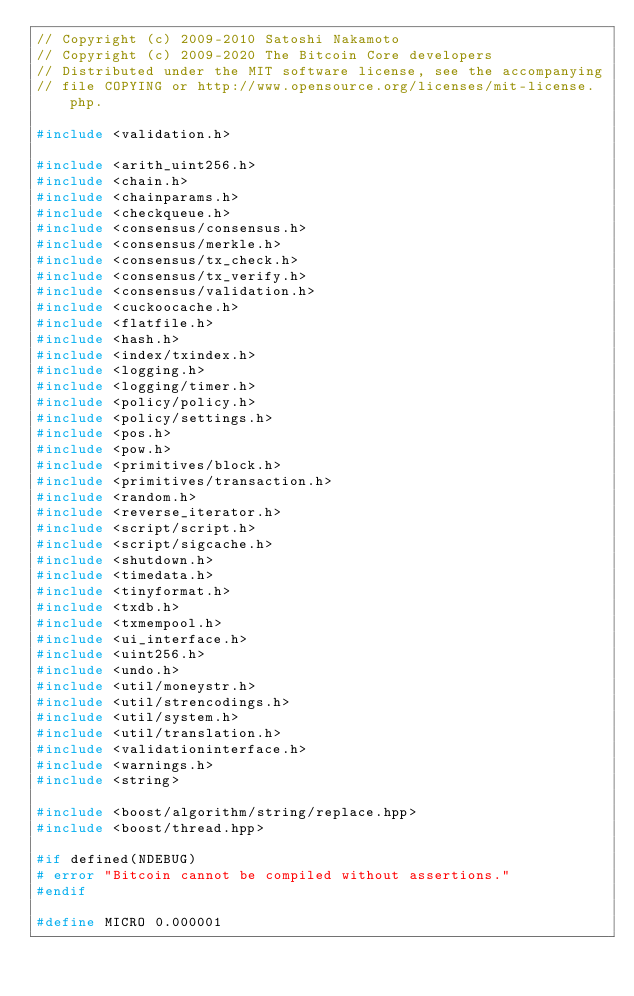Convert code to text. <code><loc_0><loc_0><loc_500><loc_500><_C++_>// Copyright (c) 2009-2010 Satoshi Nakamoto
// Copyright (c) 2009-2020 The Bitcoin Core developers
// Distributed under the MIT software license, see the accompanying
// file COPYING or http://www.opensource.org/licenses/mit-license.php.

#include <validation.h>

#include <arith_uint256.h>
#include <chain.h>
#include <chainparams.h>
#include <checkqueue.h>
#include <consensus/consensus.h>
#include <consensus/merkle.h>
#include <consensus/tx_check.h>
#include <consensus/tx_verify.h>
#include <consensus/validation.h>
#include <cuckoocache.h>
#include <flatfile.h>
#include <hash.h>
#include <index/txindex.h>
#include <logging.h>
#include <logging/timer.h>
#include <policy/policy.h>
#include <policy/settings.h>
#include <pos.h>
#include <pow.h>
#include <primitives/block.h>
#include <primitives/transaction.h>
#include <random.h>
#include <reverse_iterator.h>
#include <script/script.h>
#include <script/sigcache.h>
#include <shutdown.h>
#include <timedata.h>
#include <tinyformat.h>
#include <txdb.h>
#include <txmempool.h>
#include <ui_interface.h>
#include <uint256.h>
#include <undo.h>
#include <util/moneystr.h>
#include <util/strencodings.h>
#include <util/system.h>
#include <util/translation.h>
#include <validationinterface.h>
#include <warnings.h>
#include <string>

#include <boost/algorithm/string/replace.hpp>
#include <boost/thread.hpp>

#if defined(NDEBUG)
# error "Bitcoin cannot be compiled without assertions."
#endif

#define MICRO 0.000001</code> 